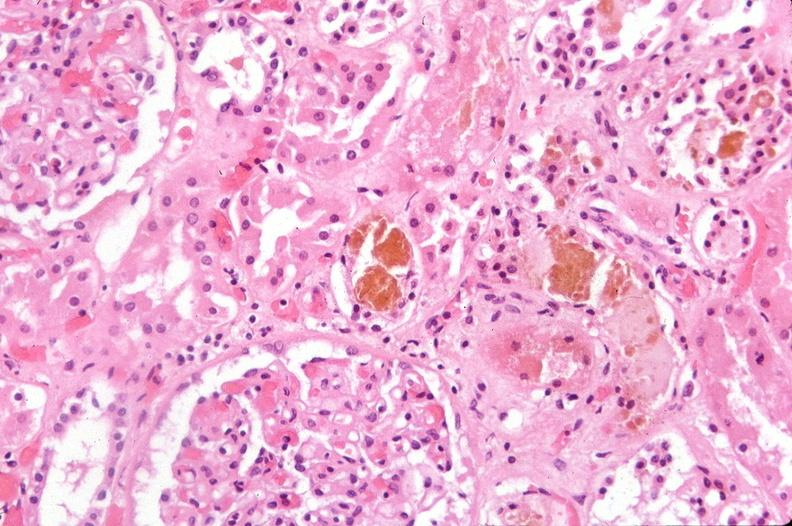does diagnosis show kidney, bile in tubules and hypercellular glomeruli mesangial proliferation?
Answer the question using a single word or phrase. No 